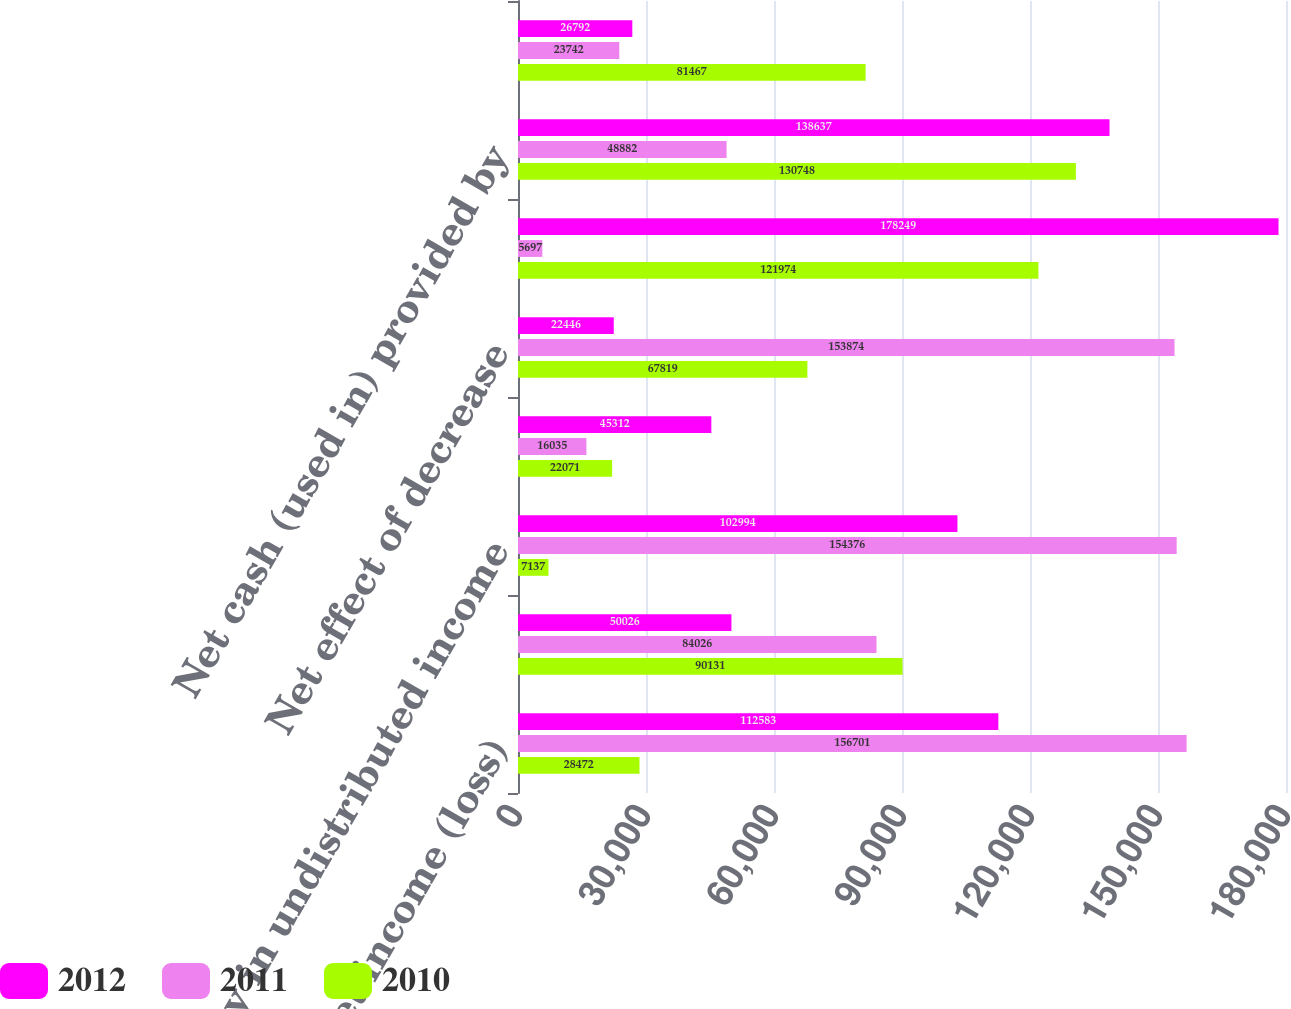Convert chart to OTSL. <chart><loc_0><loc_0><loc_500><loc_500><stacked_bar_chart><ecel><fcel>Net income (loss)<fcel>Depreciation and amortization<fcel>Equity in undistributed income<fcel>Other<fcel>Net effect of decrease<fcel>Net effect of (decrease)<fcel>Net cash (used in) provided by<fcel>Capital expenditures for<nl><fcel>2012<fcel>112583<fcel>50026<fcel>102994<fcel>45312<fcel>22446<fcel>178249<fcel>138637<fcel>26792<nl><fcel>2011<fcel>156701<fcel>84026<fcel>154376<fcel>16035<fcel>153874<fcel>5697<fcel>48882<fcel>23742<nl><fcel>2010<fcel>28472<fcel>90131<fcel>7137<fcel>22071<fcel>67819<fcel>121974<fcel>130748<fcel>81467<nl></chart> 